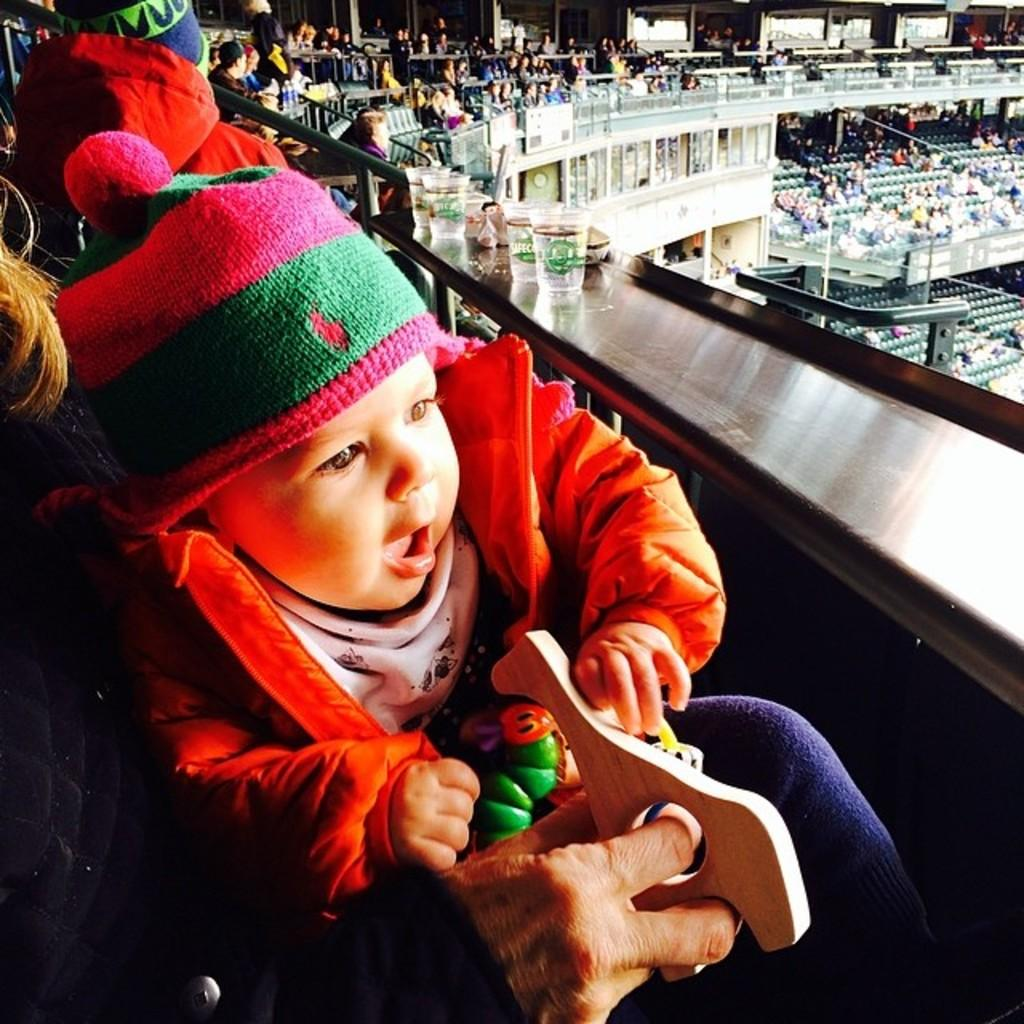What type of structure is visible in the image? There is a stadium in the image. What can be seen inside the stadium? There are people sitting in the stadium. What is the silver-colored object used for? The silver-colored object is used to hold glasses. Can you describe the baby in the image? The baby is in the image and is wearing a cap. How many letters are visible on the baby's cap in the image? There are no letters visible on the baby's cap in the image. What type of shock can be seen in the image? There is no shock present in the image. 